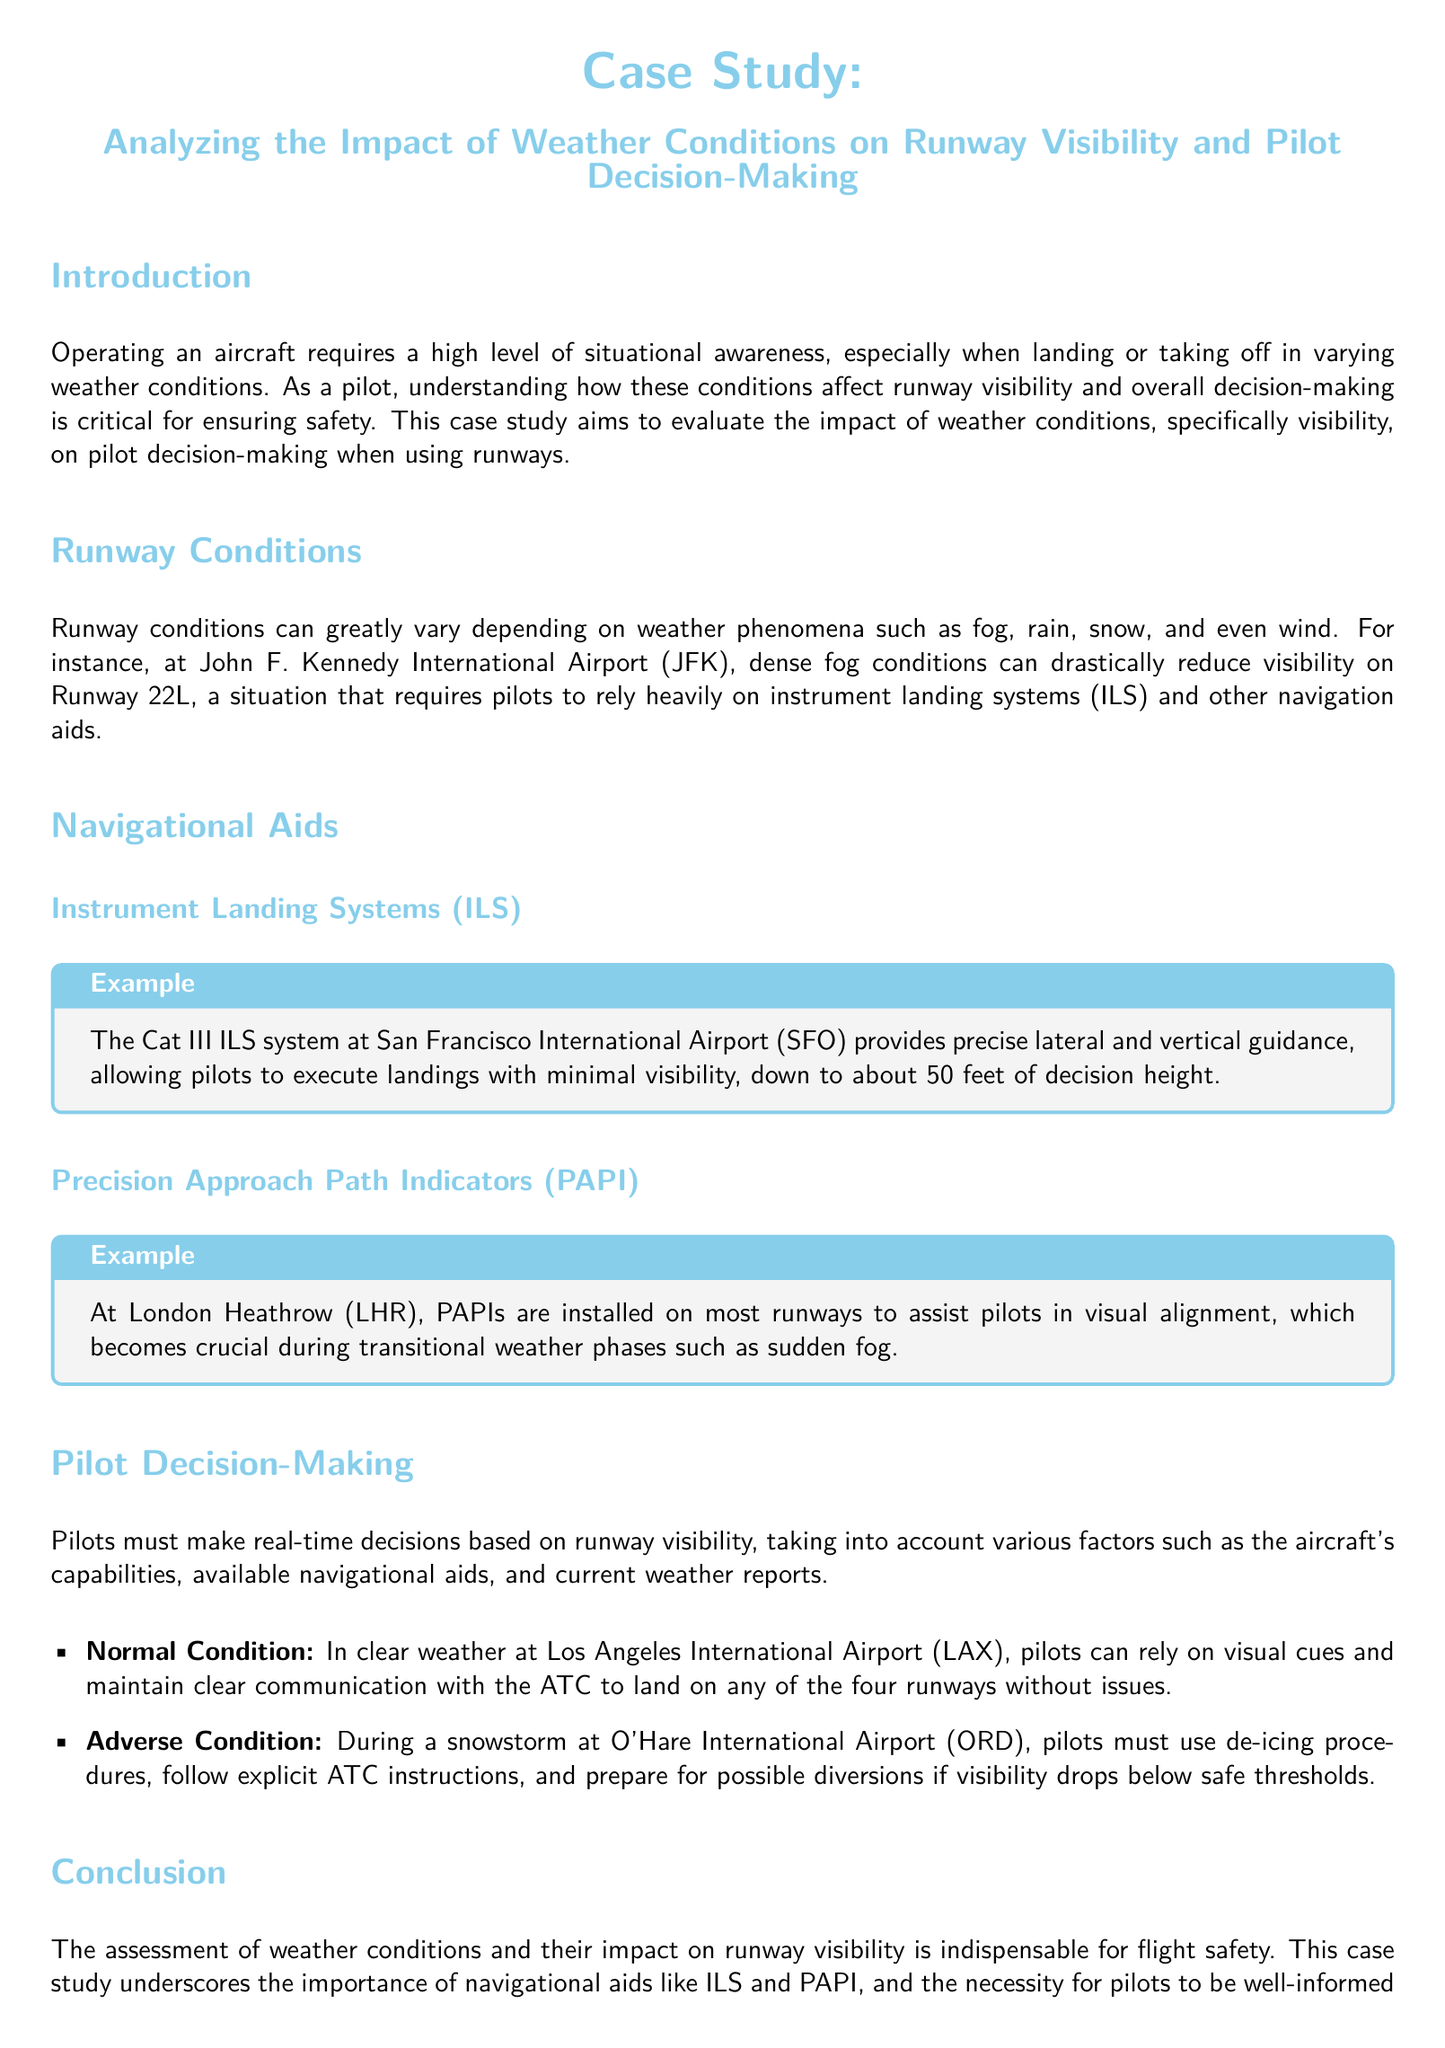What is the title of the case study? The title is mentioned prominently at the beginning of the document.
Answer: Analyzing the Impact of Weather Conditions on Runway Visibility and Pilot Decision-Making What does ILS stand for? This abbreviation is defined in the context of navigational aids in the document.
Answer: Instrument Landing Systems Which airport has a Cat III ILS system? The document provides a specific example of an airport with this system.
Answer: San Francisco International Airport What is the minimum decision height for the Cat III ILS system? This information is provided in the example related to the ILS system.
Answer: 50 feet What is a key factor for pilots during adverse conditions? The document outlines a critical consideration for pilots in poor weather.
Answer: De-icing procedures Which airport is associated with snowstorm conditions? The document references a specific airport that experiences these conditions.
Answer: O'Hare International Airport What navigational aid assists with visual alignment? This type of aid is detailed in the section on navigational aids.
Answer: Precision Approach Path Indicators What condition allows pilots to rely on visual cues? The document describes a specific scenario where this is applicable.
Answer: Normal Condition What is indispensable for flight safety? The conclusion of the document emphasizes this aspect.
Answer: Assessment of weather conditions 